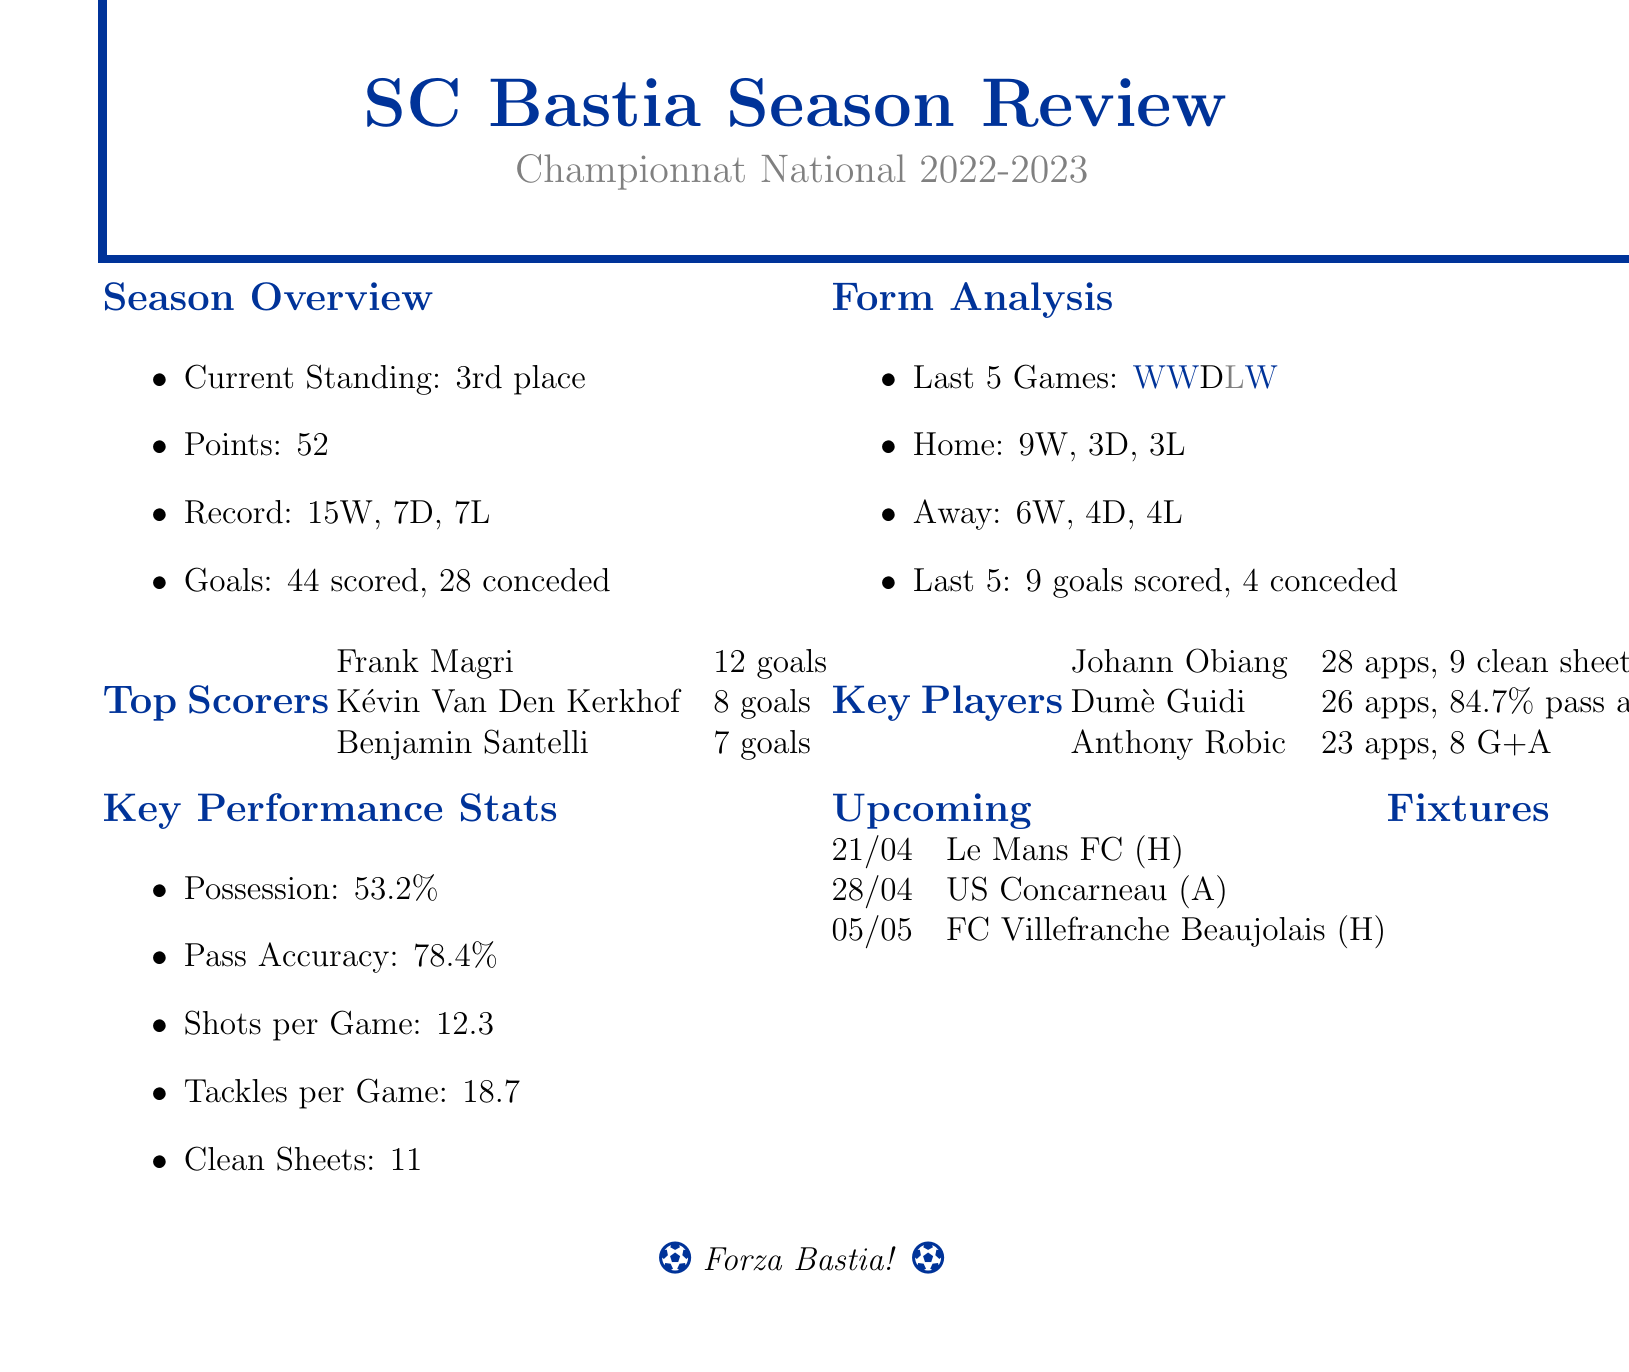What is SC Bastia's current standing? The current standing of SC Bastia in the document is mentioned as 3rd place in Championnat National.
Answer: 3rd place How many goals did Frank Magri score? According to the document, Frank Magri is the top scorer with 12 goals.
Answer: 12 goals What is the total points SC Bastia has? The document states that SC Bastia has a total of 52 points this season.
Answer: 52 points Who provided the most assists? The document indicates that Christophe Vincent is the top provider with 6 assists.
Answer: Christophe Vincent What is the team's average possession percentage? The average possession percentage mentioned in the document is 53.2%.
Answer: 53.2% How many clean sheets does Johann Obiang have? The document specifies that Johann Obiang has achieved 9 clean sheets this season.
Answer: 9 clean sheets What is the record of SC Bastia in terms of wins, draws, and losses? The record is described as 15 wins, 7 draws, and 7 losses in the document.
Answer: 15 wins, 7 draws, 7 losses What date is the upcoming match against Le Mans FC? The document lists the date of the match against Le Mans FC as April 21, 2023.
Answer: April 21, 2023 What is the average number of shots per game? The average number of shots per game provided in the document is 12.3.
Answer: 12.3 